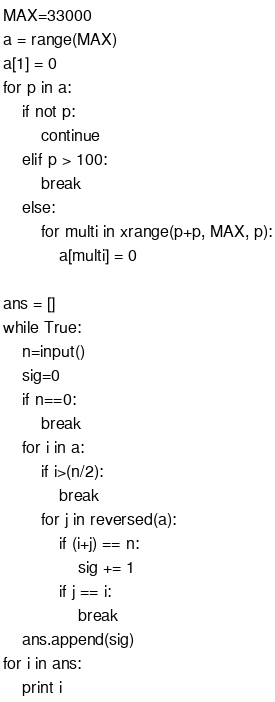Convert code to text. <code><loc_0><loc_0><loc_500><loc_500><_Python_>MAX=33000
a = range(MAX)
a[1] = 0
for p in a:
    if not p:
        continue
    elif p > 100:
        break
    else:
        for multi in xrange(p+p, MAX, p):
            a[multi] = 0

ans = []
while True:
    n=input()
    sig=0
    if n==0:
        break
    for i in a:
        if i>(n/2):
            break
        for j in reversed(a):
            if (i+j) == n:
                sig += 1
            if j == i:
                break
    ans.append(sig)
for i in ans:
    print i</code> 